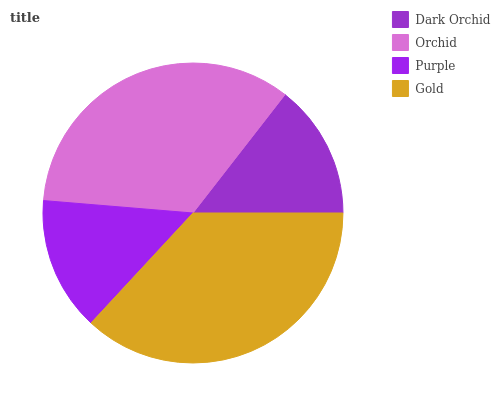Is Purple the minimum?
Answer yes or no. Yes. Is Gold the maximum?
Answer yes or no. Yes. Is Orchid the minimum?
Answer yes or no. No. Is Orchid the maximum?
Answer yes or no. No. Is Orchid greater than Dark Orchid?
Answer yes or no. Yes. Is Dark Orchid less than Orchid?
Answer yes or no. Yes. Is Dark Orchid greater than Orchid?
Answer yes or no. No. Is Orchid less than Dark Orchid?
Answer yes or no. No. Is Orchid the high median?
Answer yes or no. Yes. Is Dark Orchid the low median?
Answer yes or no. Yes. Is Purple the high median?
Answer yes or no. No. Is Gold the low median?
Answer yes or no. No. 